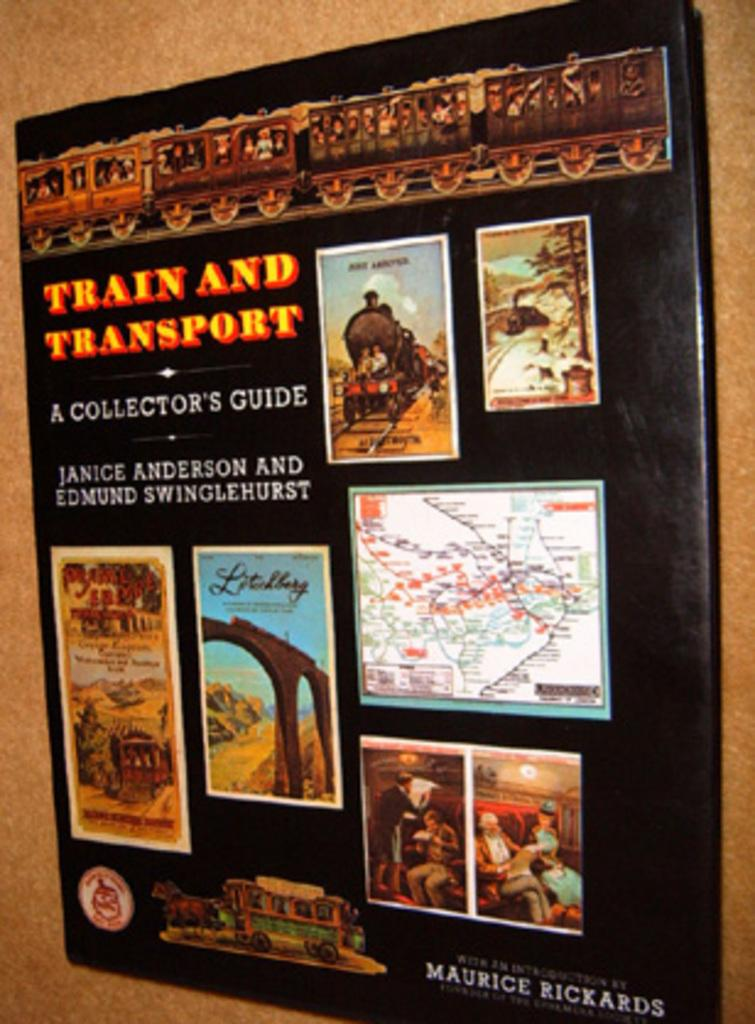<image>
Give a short and clear explanation of the subsequent image. Train and transport book with dust jacket with many pictures on cover 